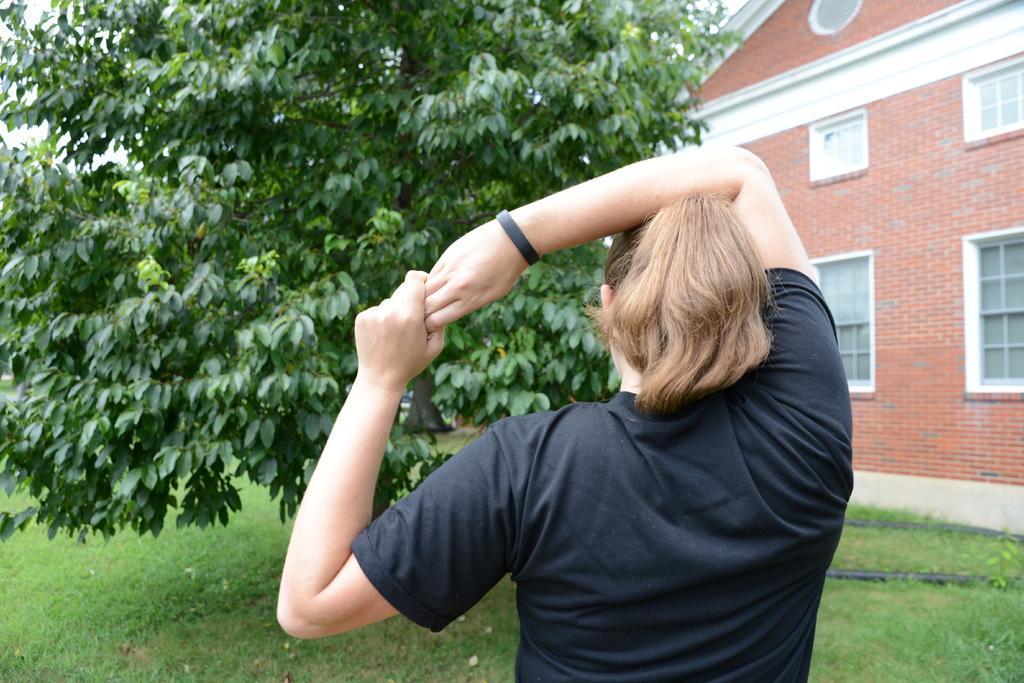Please provide a concise description of this image. In this picture we can see a house and windows. We can see tree and grass. We can see a woman wearing a black wrist band and t-shirt. 